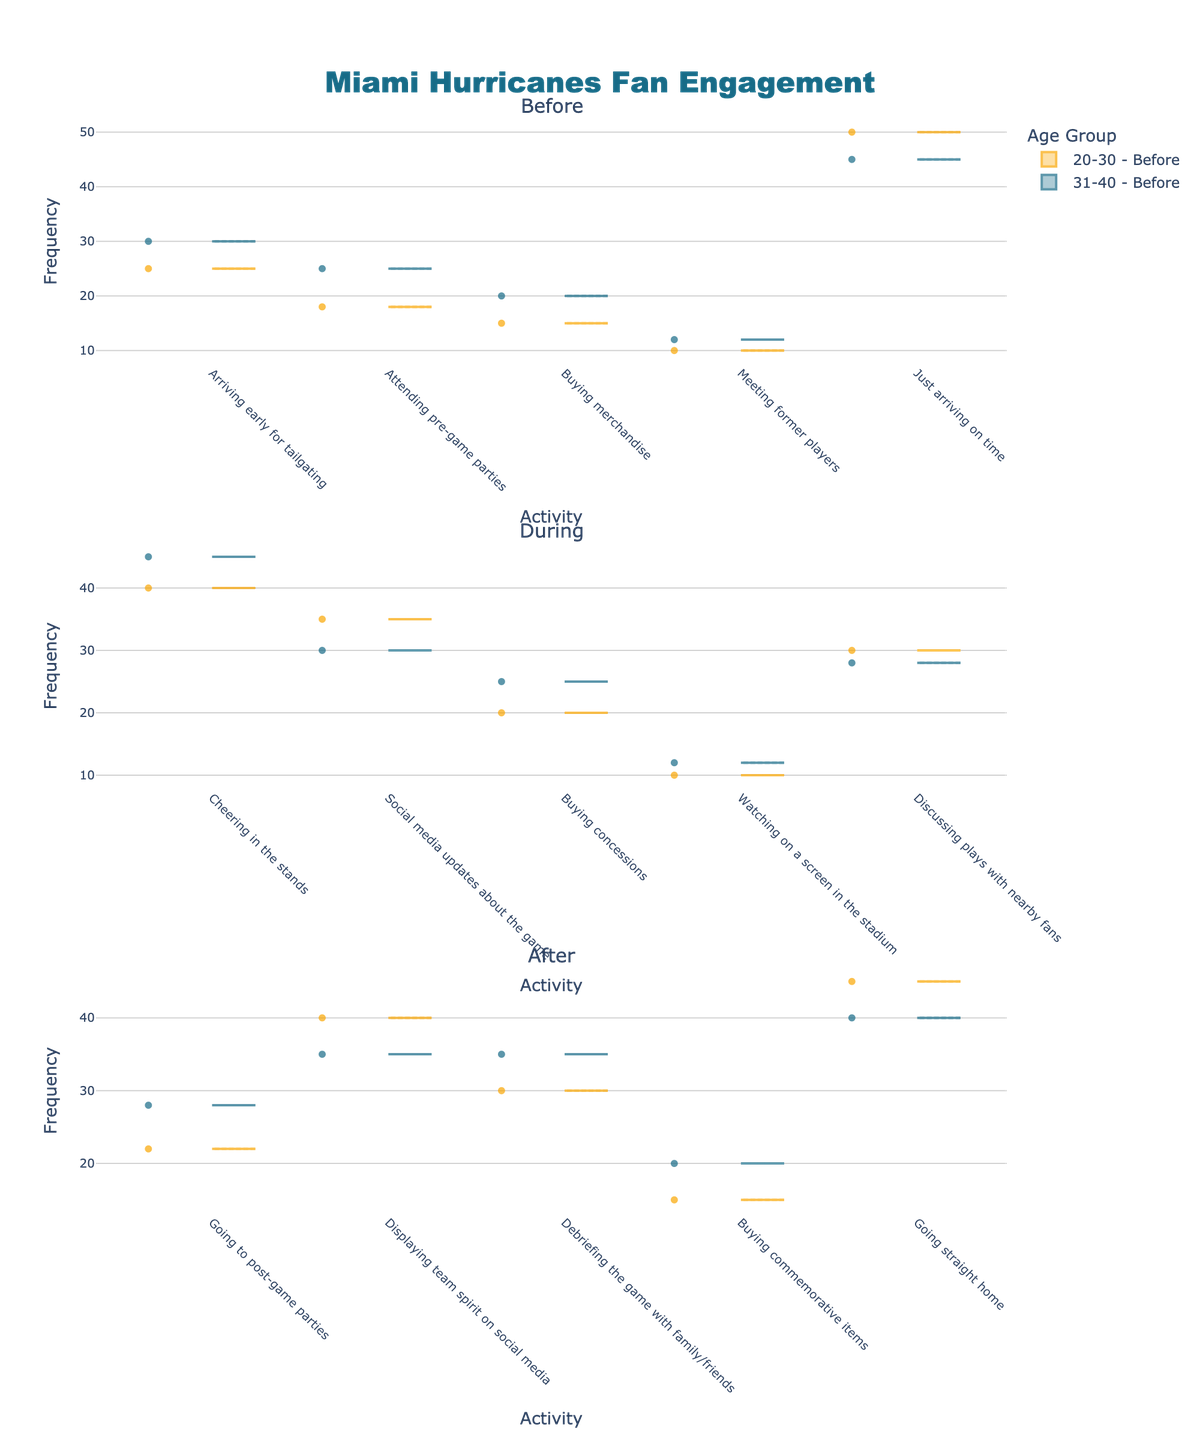What is the title of the figure? The title is typically placed at the top and often is in a larger font size compared to other text elements.
Answer: Miami Hurricanes Fan Engagement How many subplots are there in the figure? By scanning the figure, you can count the number of separate plots vertically.
Answer: Three What activity has the highest frequency for the "Before" time period among the 20-30 age group? Look at the "Before" subplot and observe the frequency for each activity.
Answer: Just arriving on time Which age group has a higher frequency for "Cheering in the stands" during the game? Compare the height of the frequency distributions for the "Cheering in the stands" activity for each age group in the "During" subplot.
Answer: 31-40 What is the range of frequencies shown for "Buying merchandise" before the game among the 31-40 age group? Observe the spread of the data points for "Buying merchandise" in the "Before" subplot for the 31-40 age group.
Answer: 20-30 Which time period has the most varied activities based on the subplot titles? Compare the number of distinct activities listed on the x-axis for each subplot.
Answer: Before During which time period do fans have the highest social media engagement, and what is the activity? Look at the frequency of social media-related activities across the different subplots to find the maximum.
Answer: After, Displaying team spirit on social media Are the median values for "Buying concessions" during the game different between the age groups? Median values are indicated by a line within the violin plot distributions; compare these lines for the "Buying concessions" activity during the game.
Answer: Yes Which activity shows a similar frequency distribution across both age groups for the "After" time period? Look for activities in the "After" subplot where the violin plots for both age groups have similar shapes and sizes.
Answer: Debriefing the game with family/friends 